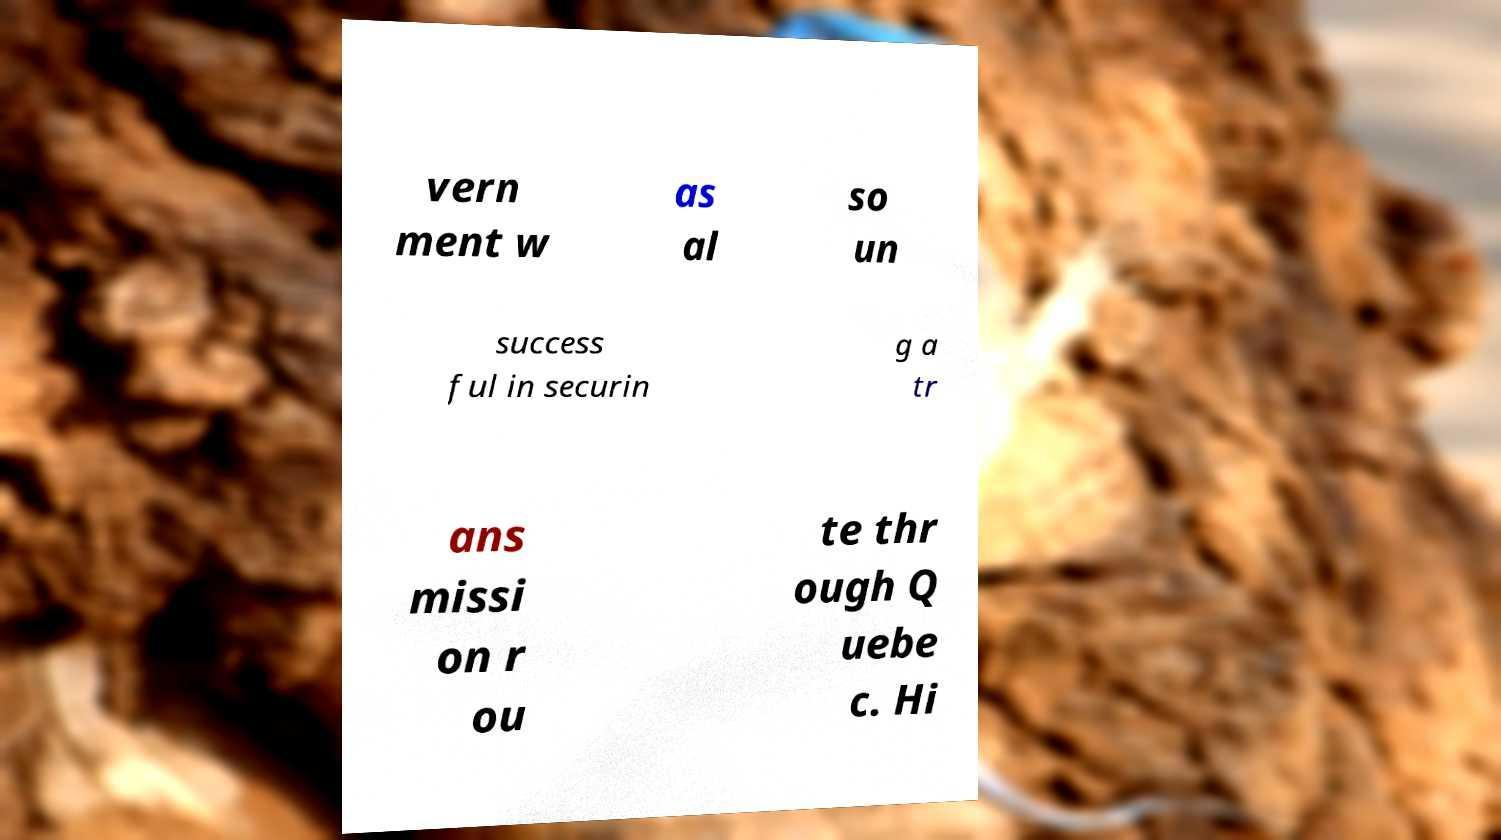Can you read and provide the text displayed in the image?This photo seems to have some interesting text. Can you extract and type it out for me? vern ment w as al so un success ful in securin g a tr ans missi on r ou te thr ough Q uebe c. Hi 